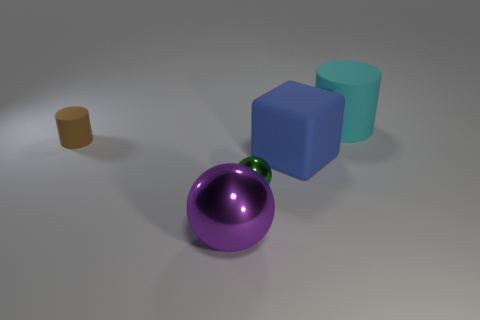Are there any small red spheres?
Give a very brief answer. No. How many blue objects are right of the rubber object to the right of the blue block?
Give a very brief answer. 0. There is a green object left of the big blue cube; what is its shape?
Offer a terse response. Sphere. What is the material of the small object that is in front of the tiny thing that is on the left side of the metallic object that is behind the purple shiny thing?
Make the answer very short. Metal. What number of other objects are there of the same size as the brown thing?
Provide a succinct answer. 1. There is another tiny object that is the same shape as the cyan object; what is it made of?
Offer a very short reply. Rubber. What color is the big metallic object?
Ensure brevity in your answer.  Purple. There is a cylinder that is on the left side of the large rubber thing that is on the right side of the blue cube; what color is it?
Give a very brief answer. Brown. There is a matte thing in front of the cylinder in front of the cyan thing; how many cylinders are behind it?
Offer a very short reply. 2. Are there any large objects to the right of the blue cube?
Give a very brief answer. Yes. 